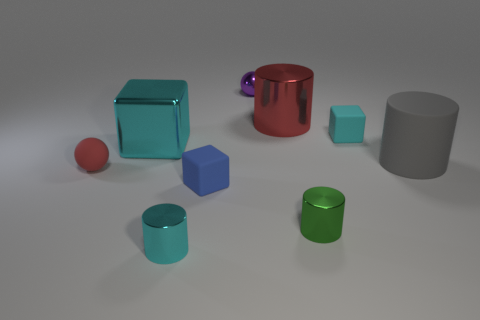Subtract all cyan cubes. How many were subtracted if there are1cyan cubes left? 1 Subtract all cyan blocks. How many blocks are left? 1 Subtract all cyan cylinders. How many cylinders are left? 3 Subtract all spheres. Subtract all small red spheres. How many objects are left? 6 Add 6 small green cylinders. How many small green cylinders are left? 7 Add 4 big purple objects. How many big purple objects exist? 4 Subtract 1 red balls. How many objects are left? 8 Subtract all blocks. How many objects are left? 6 Subtract 2 cylinders. How many cylinders are left? 2 Subtract all yellow spheres. Subtract all blue cylinders. How many spheres are left? 2 